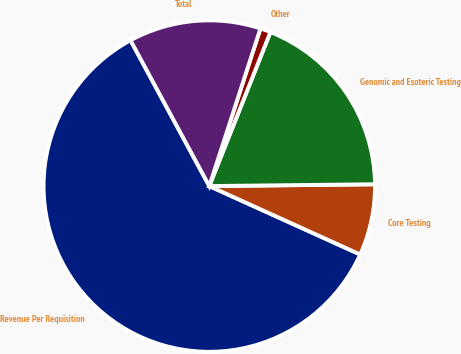Convert chart. <chart><loc_0><loc_0><loc_500><loc_500><pie_chart><fcel>Revenue Per Requisition<fcel>Core Testing<fcel>Genomic and Esoteric Testing<fcel>Other<fcel>Total<nl><fcel>60.34%<fcel>6.95%<fcel>18.81%<fcel>1.02%<fcel>12.88%<nl></chart> 